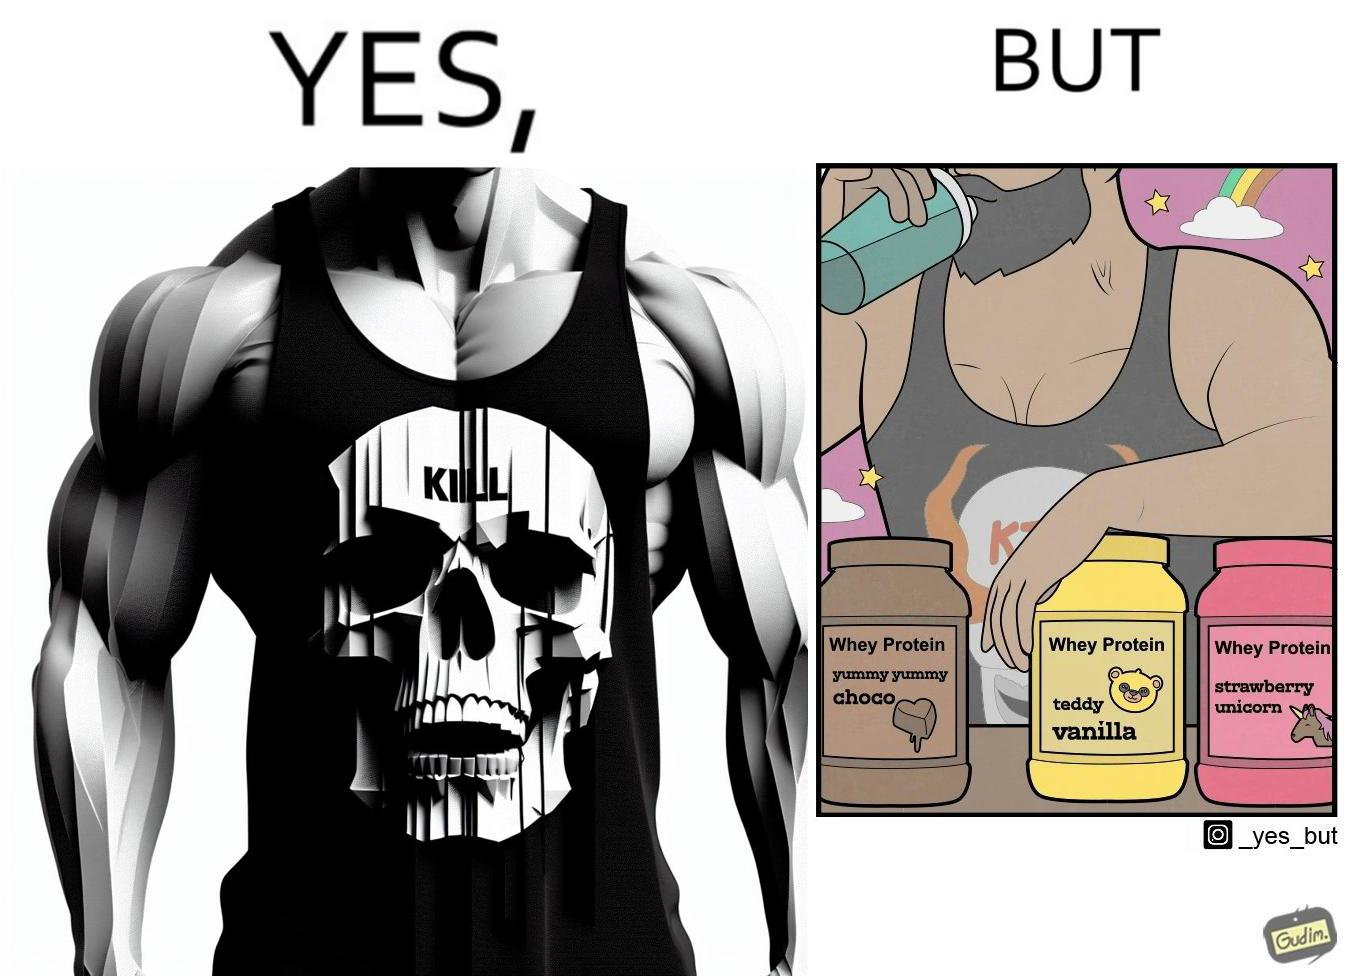Describe what you see in this image. The image is funny because a well-built person wearing an aggressive tank-top with the word "KILL" on an image of a skull is having very childish flavours of whey protein such as teddy vanilla, yummy yummy choco, and strawberry vanilla, contrary to the person's external persona. This depicts the metaphor 'Do not judge a book by its cover'. 